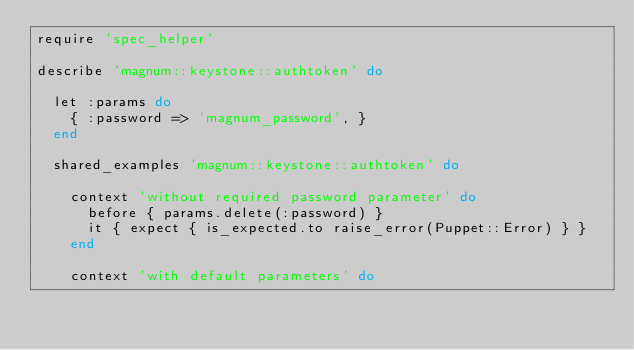Convert code to text. <code><loc_0><loc_0><loc_500><loc_500><_Ruby_>require 'spec_helper'

describe 'magnum::keystone::authtoken' do

  let :params do
    { :password => 'magnum_password', }
  end

  shared_examples 'magnum::keystone::authtoken' do

    context 'without required password parameter' do
      before { params.delete(:password) }
      it { expect { is_expected.to raise_error(Puppet::Error) } }
    end

    context 'with default parameters' do</code> 